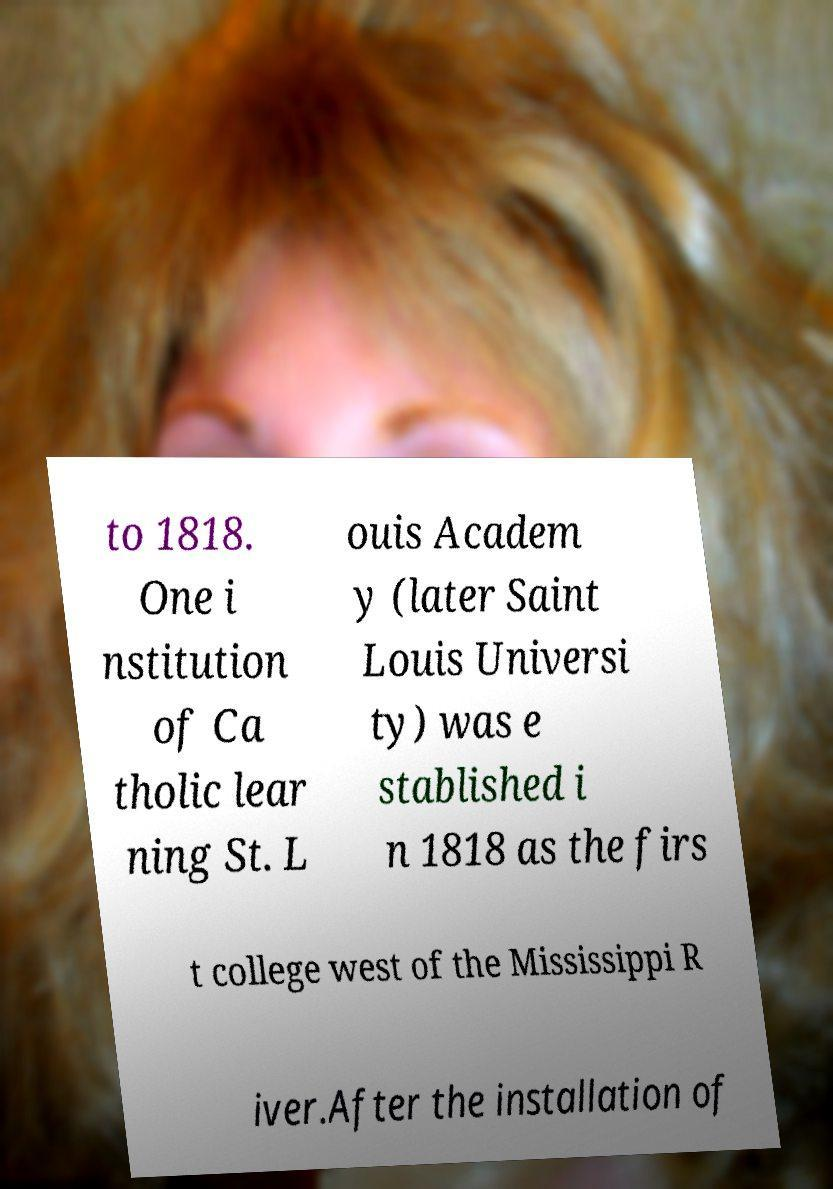Please identify and transcribe the text found in this image. to 1818. One i nstitution of Ca tholic lear ning St. L ouis Academ y (later Saint Louis Universi ty) was e stablished i n 1818 as the firs t college west of the Mississippi R iver.After the installation of 